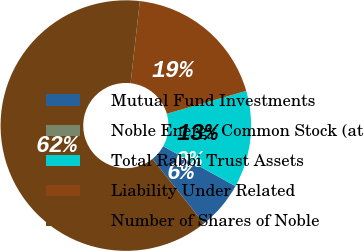Convert chart. <chart><loc_0><loc_0><loc_500><loc_500><pie_chart><fcel>Mutual Fund Investments<fcel>Noble Energy Common Stock (at<fcel>Total Rabbi Trust Assets<fcel>Liability Under Related<fcel>Number of Shares of Noble<nl><fcel>6.25%<fcel>0.0%<fcel>12.5%<fcel>18.75%<fcel>62.49%<nl></chart> 